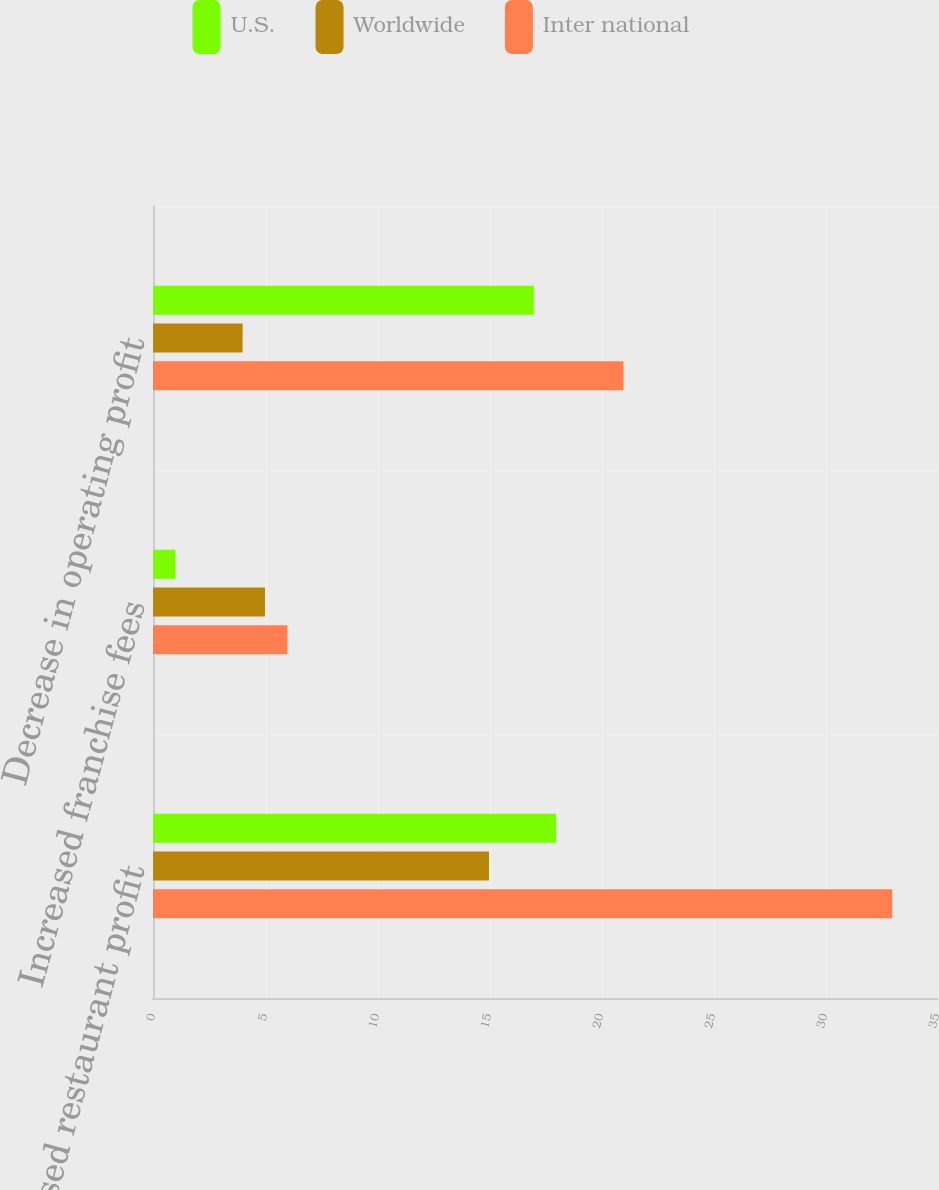Convert chart to OTSL. <chart><loc_0><loc_0><loc_500><loc_500><stacked_bar_chart><ecel><fcel>Decreased restaurant profit<fcel>Increased franchise fees<fcel>Decrease in operating profit<nl><fcel>U.S.<fcel>18<fcel>1<fcel>17<nl><fcel>Worldwide<fcel>15<fcel>5<fcel>4<nl><fcel>Inter national<fcel>33<fcel>6<fcel>21<nl></chart> 